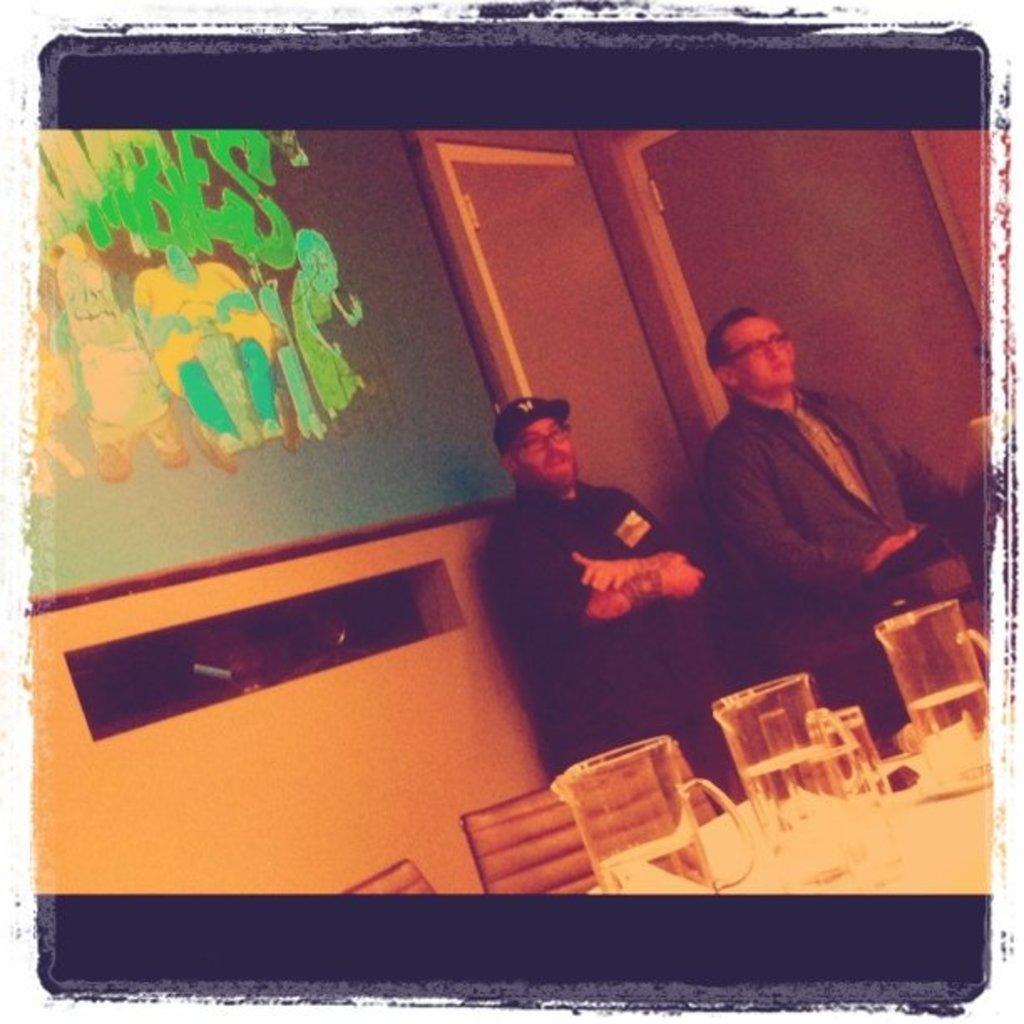Describe this image in one or two sentences. In this picture I can see few water jugs on a table, on the right side two men are standing, on the left side it looks like a projector screen. 